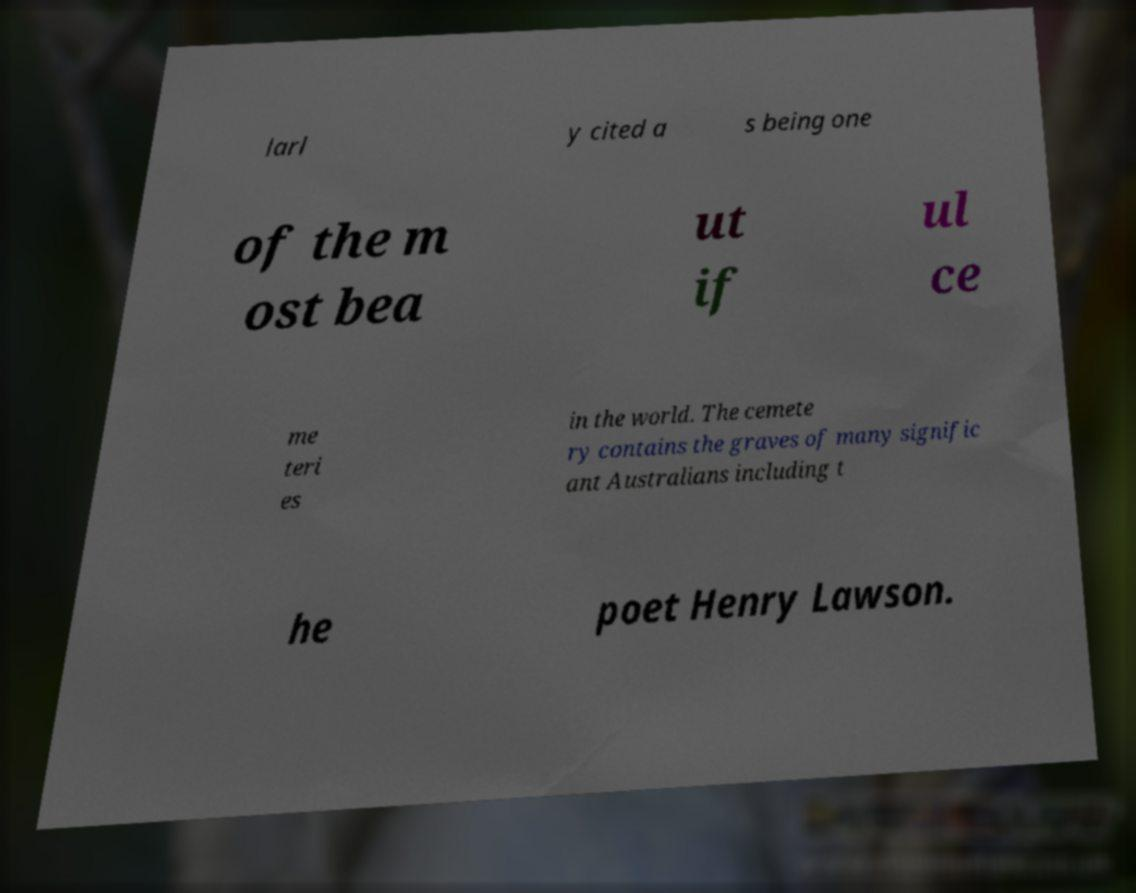Can you accurately transcribe the text from the provided image for me? larl y cited a s being one of the m ost bea ut if ul ce me teri es in the world. The cemete ry contains the graves of many signific ant Australians including t he poet Henry Lawson. 